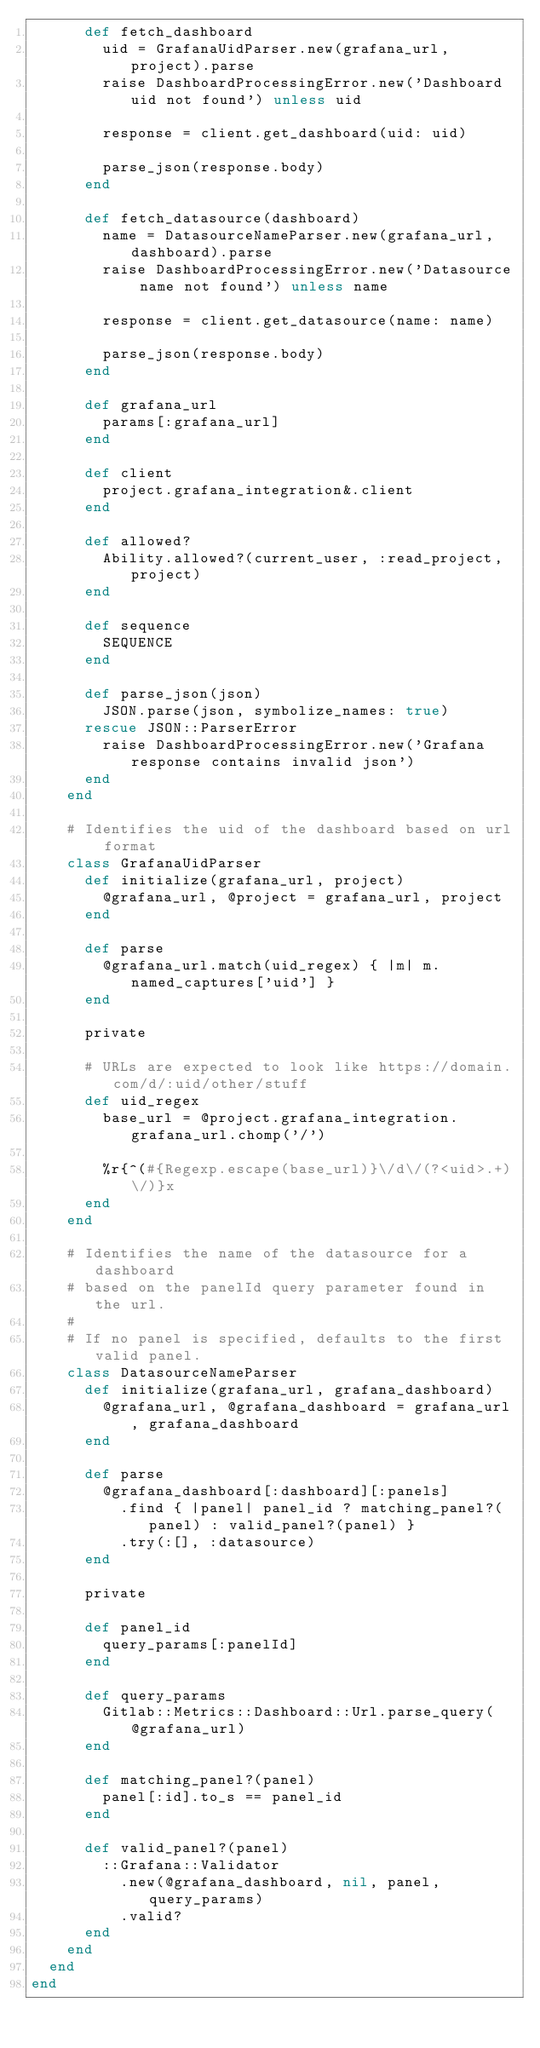Convert code to text. <code><loc_0><loc_0><loc_500><loc_500><_Ruby_>      def fetch_dashboard
        uid = GrafanaUidParser.new(grafana_url, project).parse
        raise DashboardProcessingError.new('Dashboard uid not found') unless uid

        response = client.get_dashboard(uid: uid)

        parse_json(response.body)
      end

      def fetch_datasource(dashboard)
        name = DatasourceNameParser.new(grafana_url, dashboard).parse
        raise DashboardProcessingError.new('Datasource name not found') unless name

        response = client.get_datasource(name: name)

        parse_json(response.body)
      end

      def grafana_url
        params[:grafana_url]
      end

      def client
        project.grafana_integration&.client
      end

      def allowed?
        Ability.allowed?(current_user, :read_project, project)
      end

      def sequence
        SEQUENCE
      end

      def parse_json(json)
        JSON.parse(json, symbolize_names: true)
      rescue JSON::ParserError
        raise DashboardProcessingError.new('Grafana response contains invalid json')
      end
    end

    # Identifies the uid of the dashboard based on url format
    class GrafanaUidParser
      def initialize(grafana_url, project)
        @grafana_url, @project = grafana_url, project
      end

      def parse
        @grafana_url.match(uid_regex) { |m| m.named_captures['uid'] }
      end

      private

      # URLs are expected to look like https://domain.com/d/:uid/other/stuff
      def uid_regex
        base_url = @project.grafana_integration.grafana_url.chomp('/')

        %r{^(#{Regexp.escape(base_url)}\/d\/(?<uid>.+)\/)}x
      end
    end

    # Identifies the name of the datasource for a dashboard
    # based on the panelId query parameter found in the url.
    #
    # If no panel is specified, defaults to the first valid panel.
    class DatasourceNameParser
      def initialize(grafana_url, grafana_dashboard)
        @grafana_url, @grafana_dashboard = grafana_url, grafana_dashboard
      end

      def parse
        @grafana_dashboard[:dashboard][:panels]
          .find { |panel| panel_id ? matching_panel?(panel) : valid_panel?(panel) }
          .try(:[], :datasource)
      end

      private

      def panel_id
        query_params[:panelId]
      end

      def query_params
        Gitlab::Metrics::Dashboard::Url.parse_query(@grafana_url)
      end

      def matching_panel?(panel)
        panel[:id].to_s == panel_id
      end

      def valid_panel?(panel)
        ::Grafana::Validator
          .new(@grafana_dashboard, nil, panel, query_params)
          .valid?
      end
    end
  end
end
</code> 